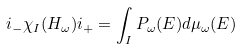Convert formula to latex. <formula><loc_0><loc_0><loc_500><loc_500>i _ { - } \chi _ { I } ( H _ { \omega } ) i _ { + } = \int _ { I } P _ { \omega } ( E ) d \mu _ { \omega } ( E )</formula> 